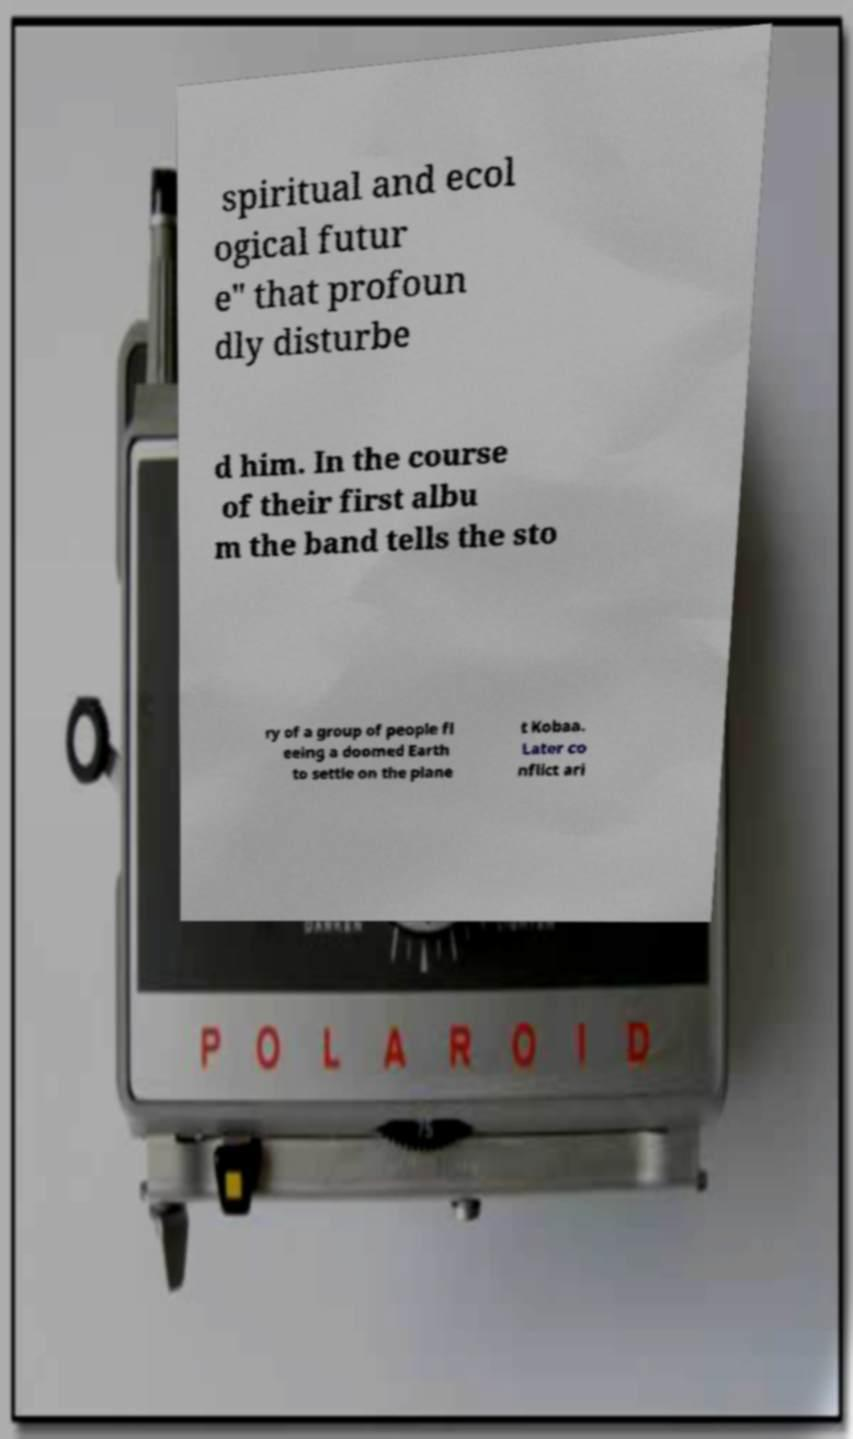Please identify and transcribe the text found in this image. spiritual and ecol ogical futur e" that profoun dly disturbe d him. In the course of their first albu m the band tells the sto ry of a group of people fl eeing a doomed Earth to settle on the plane t Kobaa. Later co nflict ari 